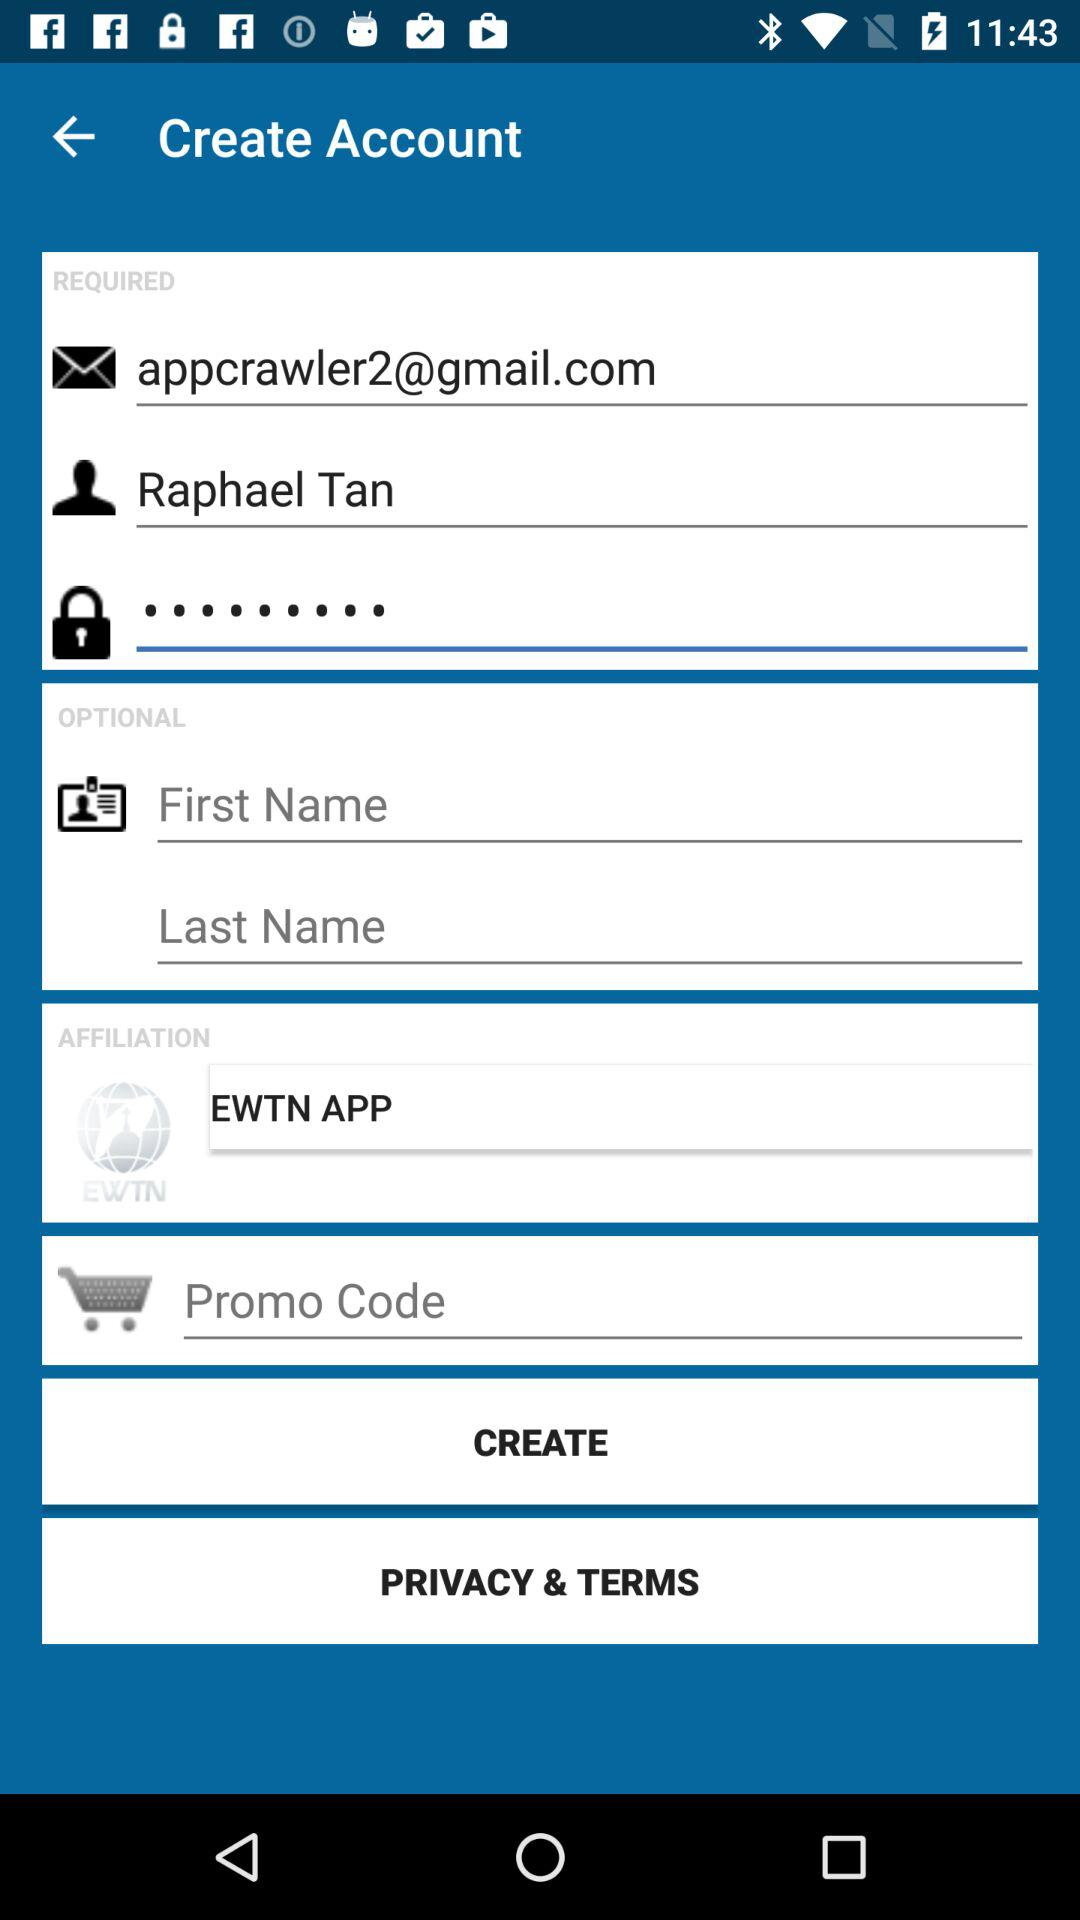Which text is written in the affiliation box? The text written in the affiliation box is "EWTN APP". 